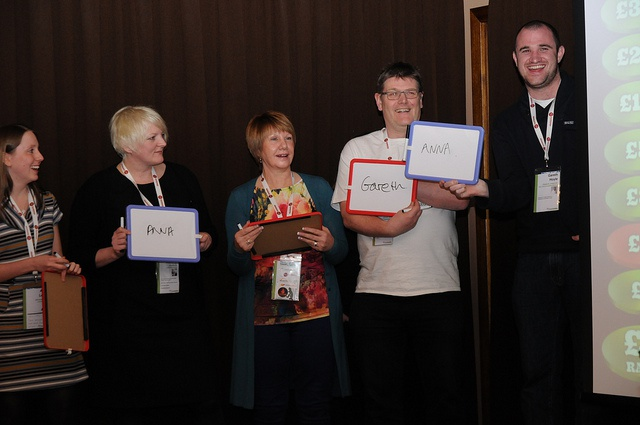Describe the objects in this image and their specific colors. I can see people in black, brown, darkgray, and gray tones, people in black, darkgray, brown, and gray tones, people in black, maroon, brown, and darkgray tones, people in black, darkgray, and gray tones, and people in black, brown, maroon, and gray tones in this image. 